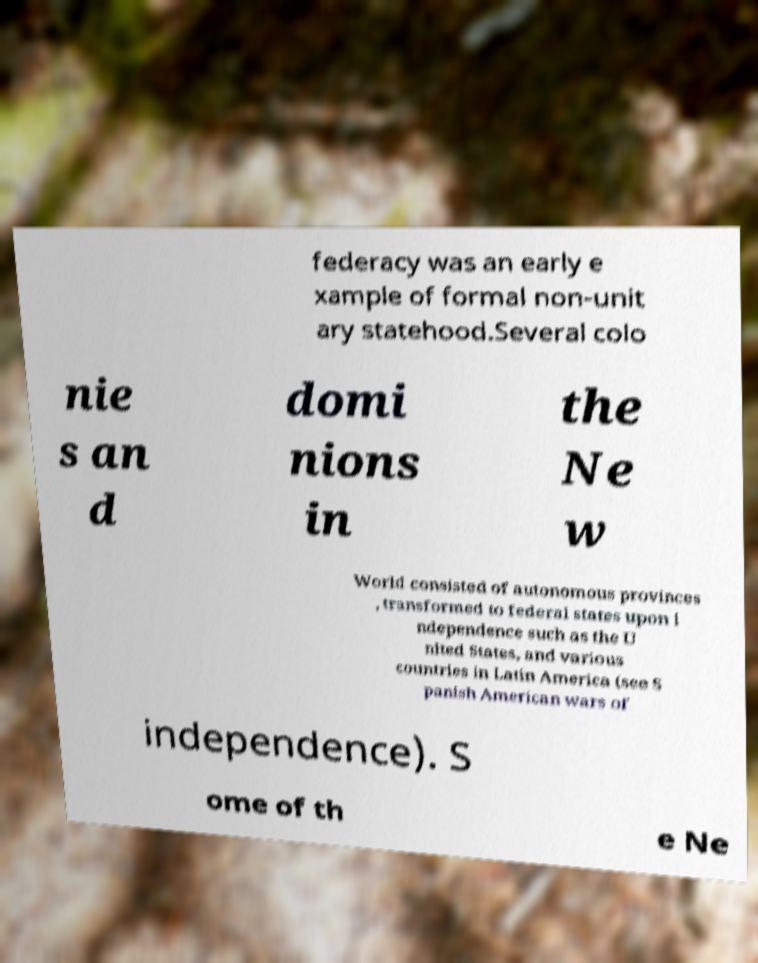Could you extract and type out the text from this image? federacy was an early e xample of formal non-unit ary statehood.Several colo nie s an d domi nions in the Ne w World consisted of autonomous provinces , transformed to federal states upon i ndependence such as the U nited States, and various countries in Latin America (see S panish American wars of independence). S ome of th e Ne 